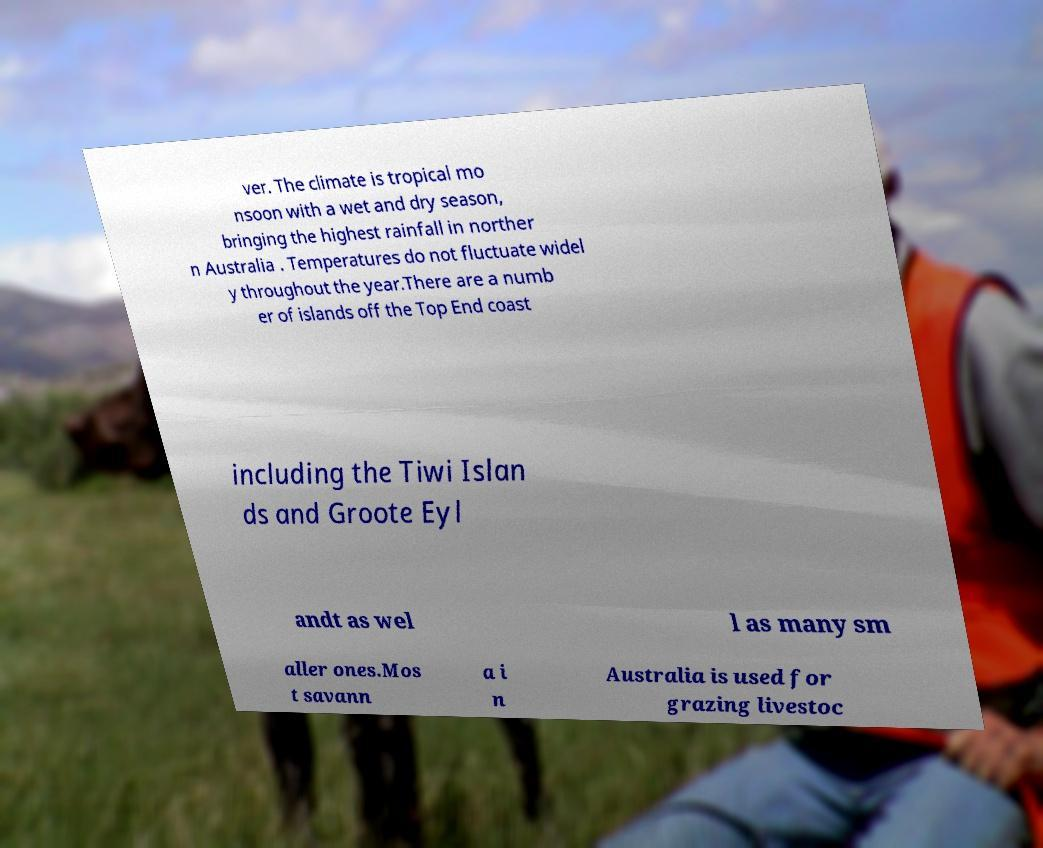Can you read and provide the text displayed in the image?This photo seems to have some interesting text. Can you extract and type it out for me? ver. The climate is tropical mo nsoon with a wet and dry season, bringing the highest rainfall in norther n Australia . Temperatures do not fluctuate widel y throughout the year.There are a numb er of islands off the Top End coast including the Tiwi Islan ds and Groote Eyl andt as wel l as many sm aller ones.Mos t savann a i n Australia is used for grazing livestoc 